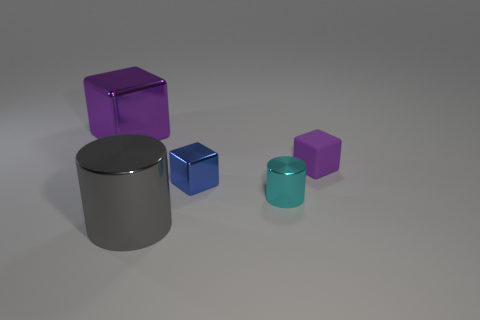Subtract all red blocks. Subtract all blue cylinders. How many blocks are left? 3 Add 5 small cubes. How many objects exist? 10 Subtract all cubes. How many objects are left? 2 Add 5 green cubes. How many green cubes exist? 5 Subtract 2 purple blocks. How many objects are left? 3 Subtract all gray metallic objects. Subtract all big gray cylinders. How many objects are left? 3 Add 2 big purple metal blocks. How many big purple metal blocks are left? 3 